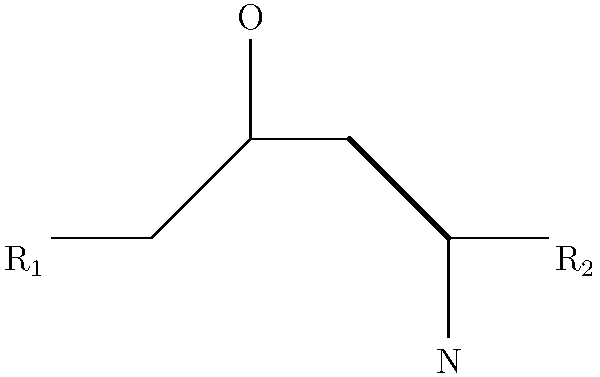In the 2D skeletal formula shown above, which functional group is present at the center of the molecule, and how might it affect the drug's behavior in the body? To answer this question, let's analyze the 2D skeletal formula step-by-step:

1. The central part of the molecule shows a carbon atom (unlabeled vertex) connected to both an oxygen (O) and a nitrogen (N) atom.

2. The arrangement of these atoms, with the oxygen double-bonded to the carbon and the nitrogen single-bonded, indicates an amide functional group.

3. Amide groups are significant in drug molecules for several reasons:
   a) They contribute to the overall polarity of the molecule, which affects solubility and distribution in the body.
   b) Amides can act as hydrogen bond acceptors (through the oxygen) and donors (through the NH if present), influencing interactions with target proteins.
   c) The amide bond is relatively stable in physiological conditions, which can affect the drug's half-life in the body.
   d) Amides can be metabolized by enzymes like peptidases, which may be relevant for the drug's clearance or activation if it's a prodrug.

4. In terms of drug behavior:
   a) The presence of an amide group can enhance water solubility, potentially improving oral bioavailability.
   b) Amides can interact with target proteins through hydrogen bonding, which may be crucial for the drug's mechanism of action.
   c) The stability of amide bonds can contribute to a longer duration of action for the drug.
   d) The amide group might be involved in the drug's metabolism, either as a site of enzymatic hydrolysis or as a metabolically stable region.

5. The R groups (R₁ and R₂) at the ends of the molecule would also play a role in the drug's overall properties and behavior, but without more information about their composition, we can't specify their effects.
Answer: Amide group; affects solubility, protein binding, stability, and metabolism. 